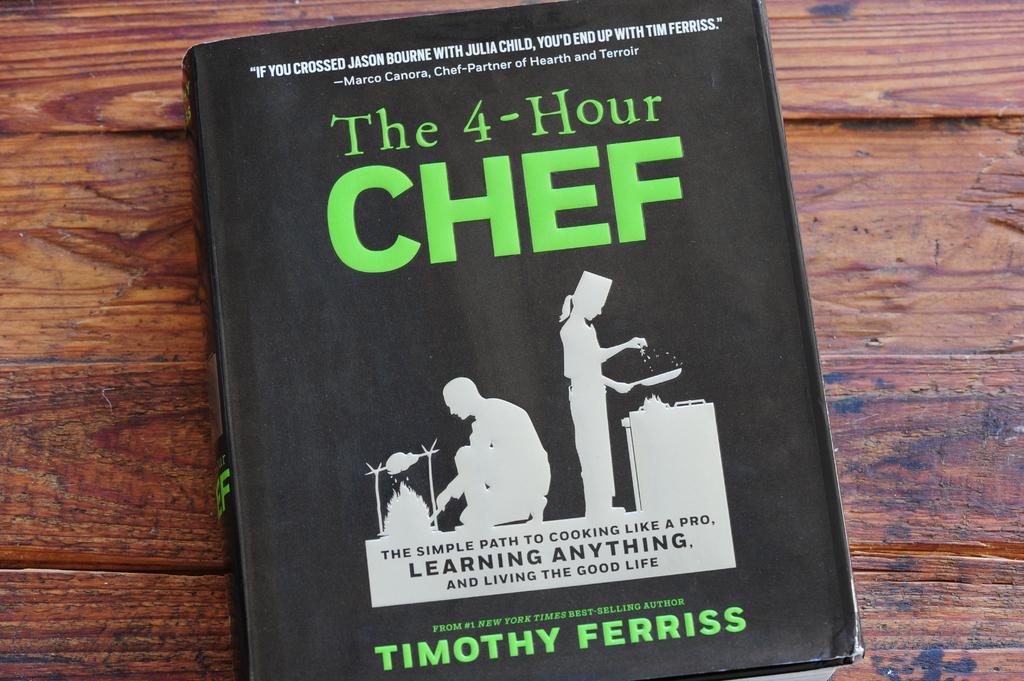Who is the author of this book?
Make the answer very short. Timothy ferriss. What is book about?
Your response must be concise. Cooking. 